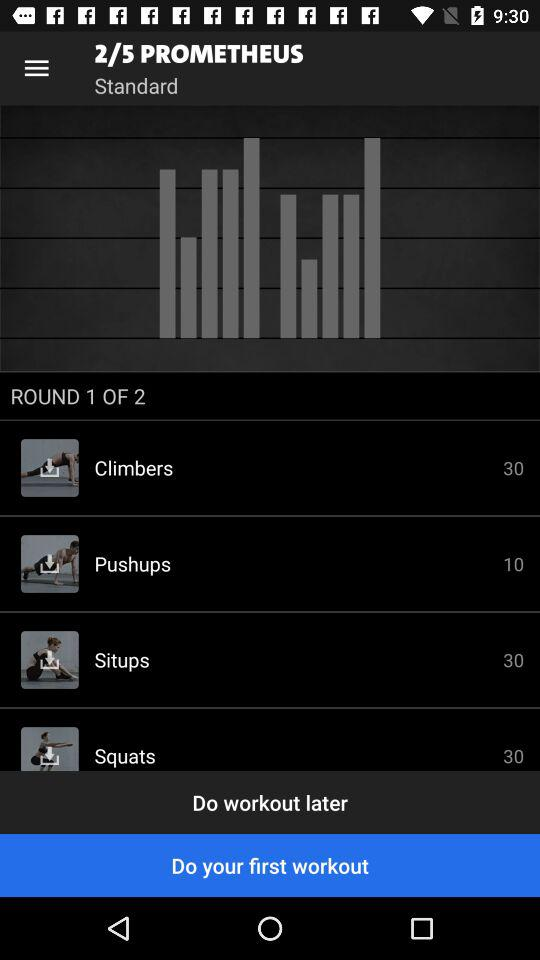How many rounds of "PROMETHEUS" are there in total? There are 5 rounds of "PROMETHEUS". 